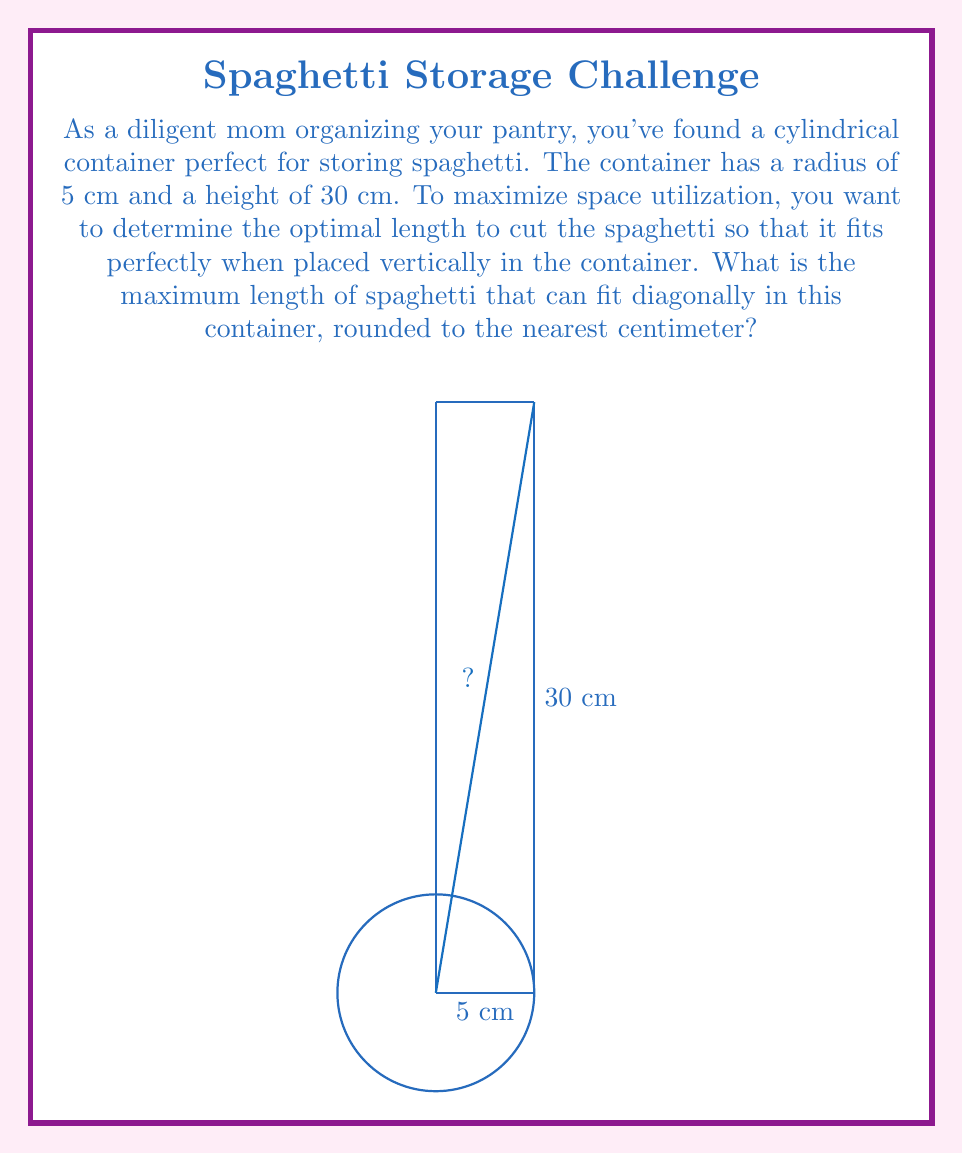Solve this math problem. Let's approach this step-by-step:

1) The spaghetti will be placed diagonally in the cylindrical container, forming the hypotenuse of a right triangle.

2) The base of this triangle is the diameter of the container (2r), and the height is the container's height (h).

3) We can use the Pythagorean theorem to find the length of the spaghetti (l):

   $$l^2 = (2r)^2 + h^2$$

4) Substituting the given values:
   r = 5 cm
   h = 30 cm

   $$l^2 = (2 * 5)^2 + 30^2$$
   $$l^2 = 10^2 + 30^2$$
   $$l^2 = 100 + 900 = 1000$$

5) Taking the square root of both sides:

   $$l = \sqrt{1000} \approx 31.62277660168379$$

6) Rounding to the nearest centimeter:

   l ≈ 32 cm

Therefore, the maximum length of spaghetti that can fit diagonally in this container is 32 cm.
Answer: 32 cm 